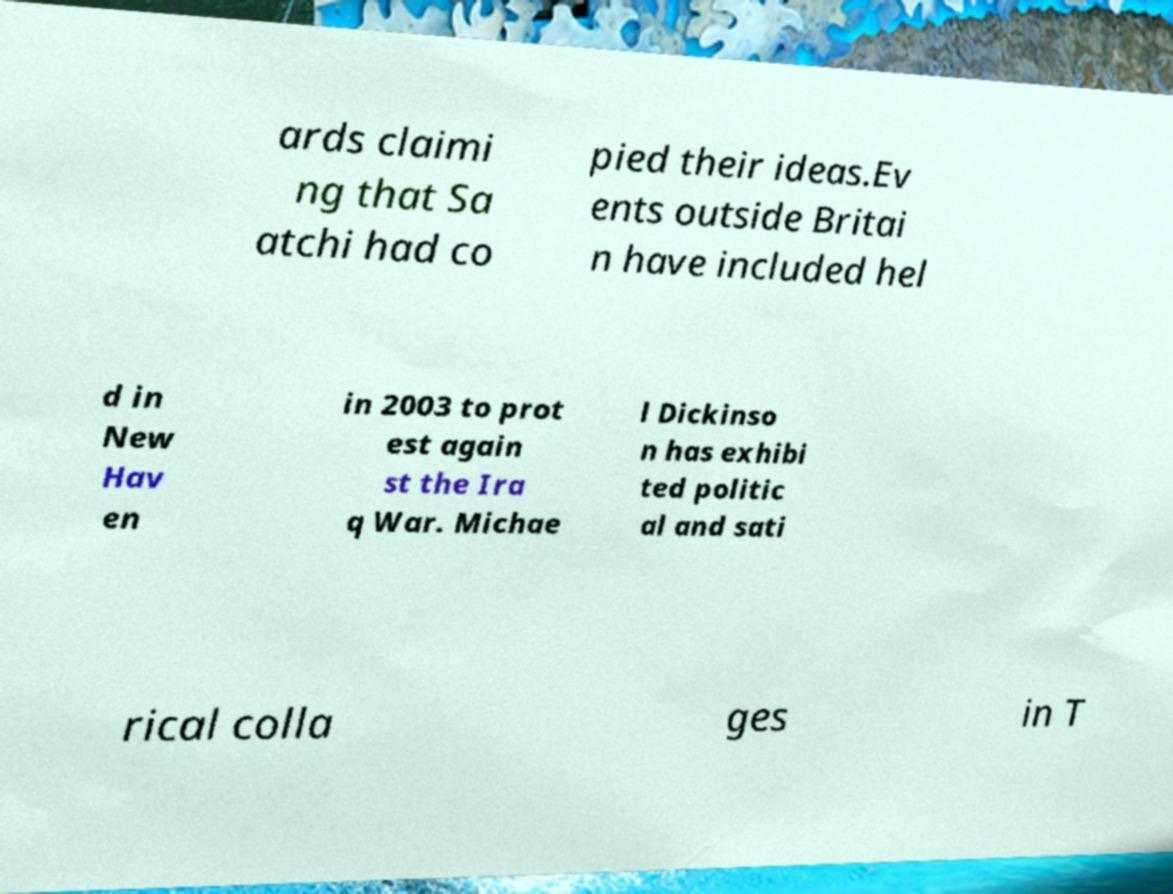Can you read and provide the text displayed in the image?This photo seems to have some interesting text. Can you extract and type it out for me? ards claimi ng that Sa atchi had co pied their ideas.Ev ents outside Britai n have included hel d in New Hav en in 2003 to prot est again st the Ira q War. Michae l Dickinso n has exhibi ted politic al and sati rical colla ges in T 